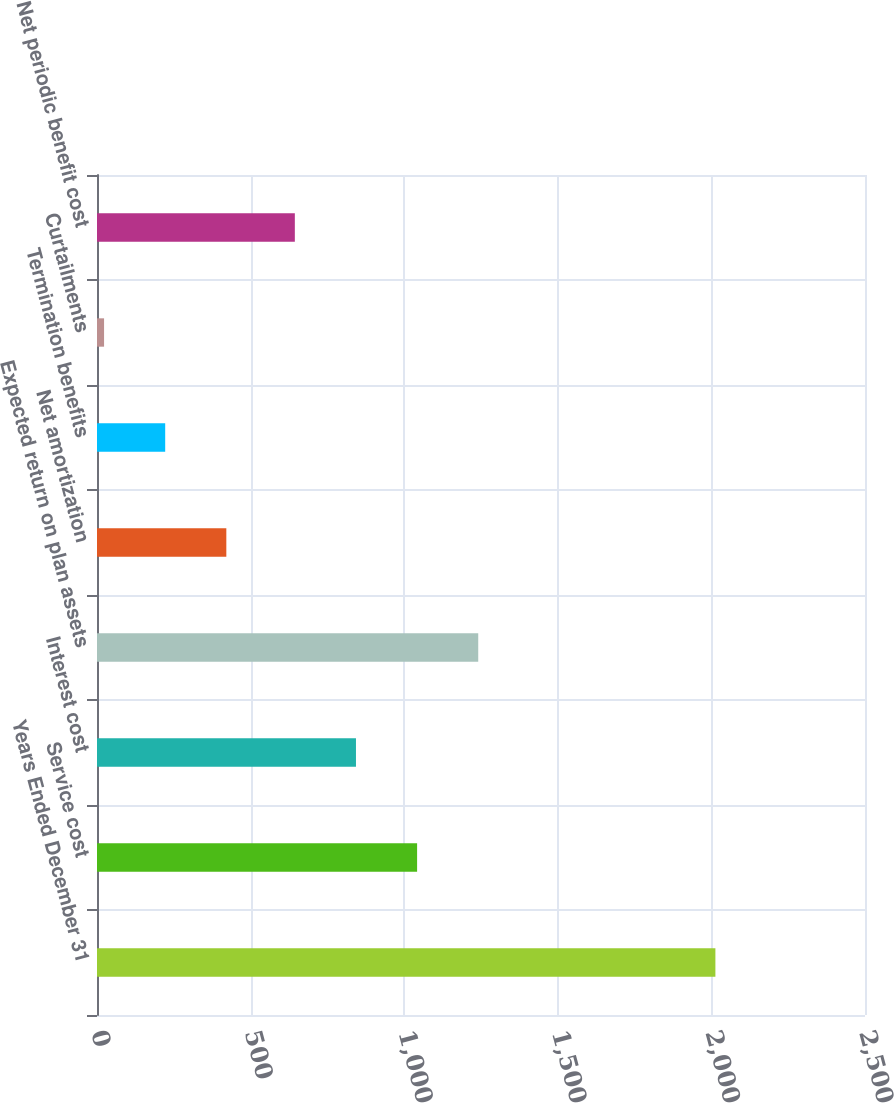Convert chart. <chart><loc_0><loc_0><loc_500><loc_500><bar_chart><fcel>Years Ended December 31<fcel>Service cost<fcel>Interest cost<fcel>Expected return on plan assets<fcel>Net amortization<fcel>Termination benefits<fcel>Curtailments<fcel>Net periodic benefit cost<nl><fcel>2013<fcel>1042<fcel>843<fcel>1241<fcel>421<fcel>222<fcel>23<fcel>644<nl></chart> 